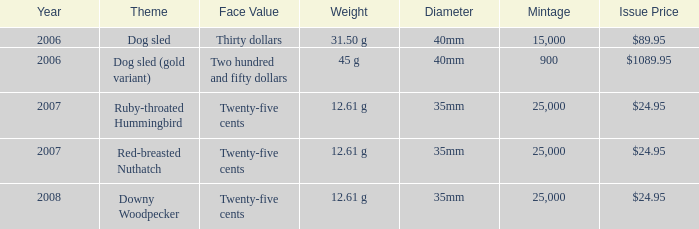What is the Diameter of the Dog Sled (gold variant) Theme coin? 40mm. 